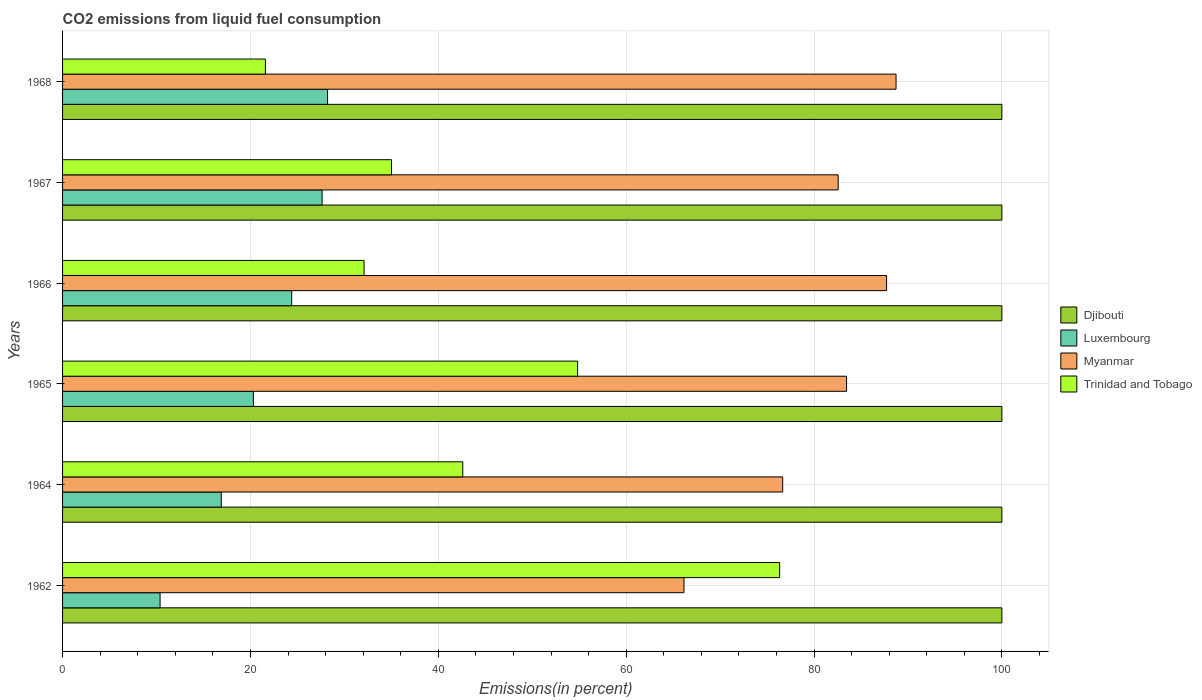How many groups of bars are there?
Your response must be concise. 6. Are the number of bars per tick equal to the number of legend labels?
Ensure brevity in your answer.  Yes. Are the number of bars on each tick of the Y-axis equal?
Your answer should be compact. Yes. What is the label of the 6th group of bars from the top?
Ensure brevity in your answer.  1962. What is the total CO2 emitted in Trinidad and Tobago in 1964?
Your response must be concise. 42.61. Across all years, what is the maximum total CO2 emitted in Trinidad and Tobago?
Offer a very short reply. 76.34. Across all years, what is the minimum total CO2 emitted in Djibouti?
Your answer should be compact. 100. In which year was the total CO2 emitted in Djibouti maximum?
Your answer should be very brief. 1962. In which year was the total CO2 emitted in Trinidad and Tobago minimum?
Give a very brief answer. 1968. What is the total total CO2 emitted in Trinidad and Tobago in the graph?
Keep it short and to the point. 262.5. What is the difference between the total CO2 emitted in Myanmar in 1967 and that in 1968?
Your answer should be very brief. -6.16. What is the difference between the total CO2 emitted in Luxembourg in 1966 and the total CO2 emitted in Myanmar in 1964?
Make the answer very short. -52.27. What is the average total CO2 emitted in Trinidad and Tobago per year?
Give a very brief answer. 43.75. In the year 1966, what is the difference between the total CO2 emitted in Trinidad and Tobago and total CO2 emitted in Luxembourg?
Keep it short and to the point. 7.71. In how many years, is the total CO2 emitted in Djibouti greater than 60 %?
Give a very brief answer. 6. What is the ratio of the total CO2 emitted in Luxembourg in 1965 to that in 1966?
Give a very brief answer. 0.83. Is the total CO2 emitted in Luxembourg in 1967 less than that in 1968?
Make the answer very short. Yes. What is the difference between the highest and the second highest total CO2 emitted in Trinidad and Tobago?
Provide a short and direct response. 21.51. What is the difference between the highest and the lowest total CO2 emitted in Trinidad and Tobago?
Make the answer very short. 54.75. Is the sum of the total CO2 emitted in Djibouti in 1966 and 1968 greater than the maximum total CO2 emitted in Myanmar across all years?
Offer a terse response. Yes. What does the 2nd bar from the top in 1966 represents?
Provide a short and direct response. Myanmar. What does the 1st bar from the bottom in 1966 represents?
Your answer should be compact. Djibouti. Is it the case that in every year, the sum of the total CO2 emitted in Djibouti and total CO2 emitted in Luxembourg is greater than the total CO2 emitted in Trinidad and Tobago?
Your answer should be very brief. Yes. Are all the bars in the graph horizontal?
Your response must be concise. Yes. How many years are there in the graph?
Offer a very short reply. 6. What is the difference between two consecutive major ticks on the X-axis?
Your answer should be compact. 20. Where does the legend appear in the graph?
Keep it short and to the point. Center right. How are the legend labels stacked?
Your answer should be very brief. Vertical. What is the title of the graph?
Offer a terse response. CO2 emissions from liquid fuel consumption. What is the label or title of the X-axis?
Your response must be concise. Emissions(in percent). What is the label or title of the Y-axis?
Keep it short and to the point. Years. What is the Emissions(in percent) in Djibouti in 1962?
Give a very brief answer. 100. What is the Emissions(in percent) of Luxembourg in 1962?
Your response must be concise. 10.38. What is the Emissions(in percent) in Myanmar in 1962?
Keep it short and to the point. 66.16. What is the Emissions(in percent) in Trinidad and Tobago in 1962?
Give a very brief answer. 76.34. What is the Emissions(in percent) of Luxembourg in 1964?
Your response must be concise. 16.9. What is the Emissions(in percent) of Myanmar in 1964?
Your response must be concise. 76.67. What is the Emissions(in percent) of Trinidad and Tobago in 1964?
Provide a succinct answer. 42.61. What is the Emissions(in percent) in Djibouti in 1965?
Your response must be concise. 100. What is the Emissions(in percent) in Luxembourg in 1965?
Make the answer very short. 20.31. What is the Emissions(in percent) of Myanmar in 1965?
Offer a very short reply. 83.47. What is the Emissions(in percent) of Trinidad and Tobago in 1965?
Your answer should be compact. 54.83. What is the Emissions(in percent) of Luxembourg in 1966?
Ensure brevity in your answer.  24.39. What is the Emissions(in percent) in Myanmar in 1966?
Provide a short and direct response. 87.73. What is the Emissions(in percent) in Trinidad and Tobago in 1966?
Make the answer very short. 32.1. What is the Emissions(in percent) in Luxembourg in 1967?
Provide a short and direct response. 27.63. What is the Emissions(in percent) of Myanmar in 1967?
Your answer should be very brief. 82.57. What is the Emissions(in percent) in Trinidad and Tobago in 1967?
Provide a short and direct response. 35.02. What is the Emissions(in percent) of Luxembourg in 1968?
Make the answer very short. 28.21. What is the Emissions(in percent) in Myanmar in 1968?
Your answer should be compact. 88.74. What is the Emissions(in percent) of Trinidad and Tobago in 1968?
Your answer should be compact. 21.6. Across all years, what is the maximum Emissions(in percent) in Djibouti?
Provide a short and direct response. 100. Across all years, what is the maximum Emissions(in percent) of Luxembourg?
Keep it short and to the point. 28.21. Across all years, what is the maximum Emissions(in percent) of Myanmar?
Provide a short and direct response. 88.74. Across all years, what is the maximum Emissions(in percent) in Trinidad and Tobago?
Keep it short and to the point. 76.34. Across all years, what is the minimum Emissions(in percent) of Djibouti?
Provide a succinct answer. 100. Across all years, what is the minimum Emissions(in percent) in Luxembourg?
Your response must be concise. 10.38. Across all years, what is the minimum Emissions(in percent) of Myanmar?
Your answer should be very brief. 66.16. Across all years, what is the minimum Emissions(in percent) of Trinidad and Tobago?
Make the answer very short. 21.6. What is the total Emissions(in percent) of Djibouti in the graph?
Your answer should be very brief. 600. What is the total Emissions(in percent) of Luxembourg in the graph?
Offer a very short reply. 127.82. What is the total Emissions(in percent) in Myanmar in the graph?
Your answer should be compact. 485.33. What is the total Emissions(in percent) of Trinidad and Tobago in the graph?
Keep it short and to the point. 262.5. What is the difference between the Emissions(in percent) in Luxembourg in 1962 and that in 1964?
Your answer should be compact. -6.51. What is the difference between the Emissions(in percent) in Myanmar in 1962 and that in 1964?
Provide a succinct answer. -10.51. What is the difference between the Emissions(in percent) of Trinidad and Tobago in 1962 and that in 1964?
Offer a terse response. 33.73. What is the difference between the Emissions(in percent) of Luxembourg in 1962 and that in 1965?
Your answer should be compact. -9.93. What is the difference between the Emissions(in percent) of Myanmar in 1962 and that in 1965?
Your response must be concise. -17.31. What is the difference between the Emissions(in percent) of Trinidad and Tobago in 1962 and that in 1965?
Provide a succinct answer. 21.51. What is the difference between the Emissions(in percent) in Djibouti in 1962 and that in 1966?
Your answer should be compact. 0. What is the difference between the Emissions(in percent) in Luxembourg in 1962 and that in 1966?
Provide a short and direct response. -14.01. What is the difference between the Emissions(in percent) in Myanmar in 1962 and that in 1966?
Offer a very short reply. -21.57. What is the difference between the Emissions(in percent) in Trinidad and Tobago in 1962 and that in 1966?
Your answer should be compact. 44.24. What is the difference between the Emissions(in percent) in Luxembourg in 1962 and that in 1967?
Provide a succinct answer. -17.25. What is the difference between the Emissions(in percent) of Myanmar in 1962 and that in 1967?
Give a very brief answer. -16.42. What is the difference between the Emissions(in percent) in Trinidad and Tobago in 1962 and that in 1967?
Give a very brief answer. 41.32. What is the difference between the Emissions(in percent) of Luxembourg in 1962 and that in 1968?
Give a very brief answer. -17.83. What is the difference between the Emissions(in percent) of Myanmar in 1962 and that in 1968?
Your answer should be very brief. -22.58. What is the difference between the Emissions(in percent) of Trinidad and Tobago in 1962 and that in 1968?
Your answer should be very brief. 54.75. What is the difference between the Emissions(in percent) in Djibouti in 1964 and that in 1965?
Provide a succinct answer. 0. What is the difference between the Emissions(in percent) in Luxembourg in 1964 and that in 1965?
Keep it short and to the point. -3.42. What is the difference between the Emissions(in percent) in Myanmar in 1964 and that in 1965?
Offer a very short reply. -6.8. What is the difference between the Emissions(in percent) in Trinidad and Tobago in 1964 and that in 1965?
Keep it short and to the point. -12.23. What is the difference between the Emissions(in percent) in Djibouti in 1964 and that in 1966?
Your response must be concise. 0. What is the difference between the Emissions(in percent) in Luxembourg in 1964 and that in 1966?
Provide a succinct answer. -7.5. What is the difference between the Emissions(in percent) of Myanmar in 1964 and that in 1966?
Your response must be concise. -11.06. What is the difference between the Emissions(in percent) of Trinidad and Tobago in 1964 and that in 1966?
Ensure brevity in your answer.  10.51. What is the difference between the Emissions(in percent) of Luxembourg in 1964 and that in 1967?
Make the answer very short. -10.74. What is the difference between the Emissions(in percent) in Myanmar in 1964 and that in 1967?
Your response must be concise. -5.91. What is the difference between the Emissions(in percent) in Trinidad and Tobago in 1964 and that in 1967?
Offer a very short reply. 7.59. What is the difference between the Emissions(in percent) of Luxembourg in 1964 and that in 1968?
Provide a short and direct response. -11.32. What is the difference between the Emissions(in percent) in Myanmar in 1964 and that in 1968?
Ensure brevity in your answer.  -12.07. What is the difference between the Emissions(in percent) of Trinidad and Tobago in 1964 and that in 1968?
Offer a terse response. 21.01. What is the difference between the Emissions(in percent) in Luxembourg in 1965 and that in 1966?
Make the answer very short. -4.08. What is the difference between the Emissions(in percent) in Myanmar in 1965 and that in 1966?
Offer a terse response. -4.26. What is the difference between the Emissions(in percent) in Trinidad and Tobago in 1965 and that in 1966?
Make the answer very short. 22.74. What is the difference between the Emissions(in percent) of Djibouti in 1965 and that in 1967?
Your answer should be compact. 0. What is the difference between the Emissions(in percent) in Luxembourg in 1965 and that in 1967?
Give a very brief answer. -7.32. What is the difference between the Emissions(in percent) of Myanmar in 1965 and that in 1967?
Provide a succinct answer. 0.89. What is the difference between the Emissions(in percent) in Trinidad and Tobago in 1965 and that in 1967?
Ensure brevity in your answer.  19.81. What is the difference between the Emissions(in percent) of Luxembourg in 1965 and that in 1968?
Offer a very short reply. -7.9. What is the difference between the Emissions(in percent) of Myanmar in 1965 and that in 1968?
Your response must be concise. -5.27. What is the difference between the Emissions(in percent) of Trinidad and Tobago in 1965 and that in 1968?
Offer a very short reply. 33.24. What is the difference between the Emissions(in percent) of Luxembourg in 1966 and that in 1967?
Keep it short and to the point. -3.24. What is the difference between the Emissions(in percent) of Myanmar in 1966 and that in 1967?
Make the answer very short. 5.16. What is the difference between the Emissions(in percent) of Trinidad and Tobago in 1966 and that in 1967?
Your response must be concise. -2.92. What is the difference between the Emissions(in percent) of Luxembourg in 1966 and that in 1968?
Keep it short and to the point. -3.82. What is the difference between the Emissions(in percent) of Myanmar in 1966 and that in 1968?
Keep it short and to the point. -1.01. What is the difference between the Emissions(in percent) of Trinidad and Tobago in 1966 and that in 1968?
Your response must be concise. 10.5. What is the difference between the Emissions(in percent) of Luxembourg in 1967 and that in 1968?
Offer a very short reply. -0.58. What is the difference between the Emissions(in percent) in Myanmar in 1967 and that in 1968?
Your answer should be compact. -6.16. What is the difference between the Emissions(in percent) in Trinidad and Tobago in 1967 and that in 1968?
Offer a very short reply. 13.42. What is the difference between the Emissions(in percent) of Djibouti in 1962 and the Emissions(in percent) of Luxembourg in 1964?
Your answer should be very brief. 83.1. What is the difference between the Emissions(in percent) of Djibouti in 1962 and the Emissions(in percent) of Myanmar in 1964?
Ensure brevity in your answer.  23.33. What is the difference between the Emissions(in percent) in Djibouti in 1962 and the Emissions(in percent) in Trinidad and Tobago in 1964?
Your response must be concise. 57.39. What is the difference between the Emissions(in percent) in Luxembourg in 1962 and the Emissions(in percent) in Myanmar in 1964?
Offer a very short reply. -66.29. What is the difference between the Emissions(in percent) in Luxembourg in 1962 and the Emissions(in percent) in Trinidad and Tobago in 1964?
Your response must be concise. -32.23. What is the difference between the Emissions(in percent) of Myanmar in 1962 and the Emissions(in percent) of Trinidad and Tobago in 1964?
Your response must be concise. 23.55. What is the difference between the Emissions(in percent) in Djibouti in 1962 and the Emissions(in percent) in Luxembourg in 1965?
Your answer should be very brief. 79.69. What is the difference between the Emissions(in percent) in Djibouti in 1962 and the Emissions(in percent) in Myanmar in 1965?
Make the answer very short. 16.53. What is the difference between the Emissions(in percent) of Djibouti in 1962 and the Emissions(in percent) of Trinidad and Tobago in 1965?
Keep it short and to the point. 45.17. What is the difference between the Emissions(in percent) of Luxembourg in 1962 and the Emissions(in percent) of Myanmar in 1965?
Offer a very short reply. -73.09. What is the difference between the Emissions(in percent) in Luxembourg in 1962 and the Emissions(in percent) in Trinidad and Tobago in 1965?
Offer a terse response. -44.45. What is the difference between the Emissions(in percent) in Myanmar in 1962 and the Emissions(in percent) in Trinidad and Tobago in 1965?
Your answer should be compact. 11.32. What is the difference between the Emissions(in percent) in Djibouti in 1962 and the Emissions(in percent) in Luxembourg in 1966?
Ensure brevity in your answer.  75.61. What is the difference between the Emissions(in percent) in Djibouti in 1962 and the Emissions(in percent) in Myanmar in 1966?
Provide a succinct answer. 12.27. What is the difference between the Emissions(in percent) of Djibouti in 1962 and the Emissions(in percent) of Trinidad and Tobago in 1966?
Make the answer very short. 67.9. What is the difference between the Emissions(in percent) in Luxembourg in 1962 and the Emissions(in percent) in Myanmar in 1966?
Your response must be concise. -77.35. What is the difference between the Emissions(in percent) of Luxembourg in 1962 and the Emissions(in percent) of Trinidad and Tobago in 1966?
Your answer should be very brief. -21.72. What is the difference between the Emissions(in percent) in Myanmar in 1962 and the Emissions(in percent) in Trinidad and Tobago in 1966?
Offer a terse response. 34.06. What is the difference between the Emissions(in percent) of Djibouti in 1962 and the Emissions(in percent) of Luxembourg in 1967?
Your answer should be compact. 72.37. What is the difference between the Emissions(in percent) in Djibouti in 1962 and the Emissions(in percent) in Myanmar in 1967?
Your response must be concise. 17.43. What is the difference between the Emissions(in percent) of Djibouti in 1962 and the Emissions(in percent) of Trinidad and Tobago in 1967?
Your answer should be compact. 64.98. What is the difference between the Emissions(in percent) in Luxembourg in 1962 and the Emissions(in percent) in Myanmar in 1967?
Your answer should be very brief. -72.19. What is the difference between the Emissions(in percent) in Luxembourg in 1962 and the Emissions(in percent) in Trinidad and Tobago in 1967?
Provide a short and direct response. -24.64. What is the difference between the Emissions(in percent) of Myanmar in 1962 and the Emissions(in percent) of Trinidad and Tobago in 1967?
Provide a short and direct response. 31.14. What is the difference between the Emissions(in percent) of Djibouti in 1962 and the Emissions(in percent) of Luxembourg in 1968?
Provide a succinct answer. 71.79. What is the difference between the Emissions(in percent) in Djibouti in 1962 and the Emissions(in percent) in Myanmar in 1968?
Make the answer very short. 11.26. What is the difference between the Emissions(in percent) in Djibouti in 1962 and the Emissions(in percent) in Trinidad and Tobago in 1968?
Offer a very short reply. 78.4. What is the difference between the Emissions(in percent) of Luxembourg in 1962 and the Emissions(in percent) of Myanmar in 1968?
Your answer should be very brief. -78.36. What is the difference between the Emissions(in percent) in Luxembourg in 1962 and the Emissions(in percent) in Trinidad and Tobago in 1968?
Offer a very short reply. -11.22. What is the difference between the Emissions(in percent) in Myanmar in 1962 and the Emissions(in percent) in Trinidad and Tobago in 1968?
Your answer should be compact. 44.56. What is the difference between the Emissions(in percent) in Djibouti in 1964 and the Emissions(in percent) in Luxembourg in 1965?
Make the answer very short. 79.69. What is the difference between the Emissions(in percent) in Djibouti in 1964 and the Emissions(in percent) in Myanmar in 1965?
Offer a very short reply. 16.53. What is the difference between the Emissions(in percent) of Djibouti in 1964 and the Emissions(in percent) of Trinidad and Tobago in 1965?
Offer a terse response. 45.17. What is the difference between the Emissions(in percent) of Luxembourg in 1964 and the Emissions(in percent) of Myanmar in 1965?
Your answer should be very brief. -66.57. What is the difference between the Emissions(in percent) in Luxembourg in 1964 and the Emissions(in percent) in Trinidad and Tobago in 1965?
Keep it short and to the point. -37.94. What is the difference between the Emissions(in percent) in Myanmar in 1964 and the Emissions(in percent) in Trinidad and Tobago in 1965?
Provide a short and direct response. 21.83. What is the difference between the Emissions(in percent) in Djibouti in 1964 and the Emissions(in percent) in Luxembourg in 1966?
Offer a terse response. 75.61. What is the difference between the Emissions(in percent) of Djibouti in 1964 and the Emissions(in percent) of Myanmar in 1966?
Give a very brief answer. 12.27. What is the difference between the Emissions(in percent) in Djibouti in 1964 and the Emissions(in percent) in Trinidad and Tobago in 1966?
Your answer should be compact. 67.9. What is the difference between the Emissions(in percent) of Luxembourg in 1964 and the Emissions(in percent) of Myanmar in 1966?
Provide a short and direct response. -70.83. What is the difference between the Emissions(in percent) in Luxembourg in 1964 and the Emissions(in percent) in Trinidad and Tobago in 1966?
Keep it short and to the point. -15.2. What is the difference between the Emissions(in percent) in Myanmar in 1964 and the Emissions(in percent) in Trinidad and Tobago in 1966?
Your answer should be very brief. 44.57. What is the difference between the Emissions(in percent) in Djibouti in 1964 and the Emissions(in percent) in Luxembourg in 1967?
Your response must be concise. 72.37. What is the difference between the Emissions(in percent) in Djibouti in 1964 and the Emissions(in percent) in Myanmar in 1967?
Give a very brief answer. 17.43. What is the difference between the Emissions(in percent) in Djibouti in 1964 and the Emissions(in percent) in Trinidad and Tobago in 1967?
Offer a very short reply. 64.98. What is the difference between the Emissions(in percent) of Luxembourg in 1964 and the Emissions(in percent) of Myanmar in 1967?
Provide a succinct answer. -65.68. What is the difference between the Emissions(in percent) in Luxembourg in 1964 and the Emissions(in percent) in Trinidad and Tobago in 1967?
Provide a succinct answer. -18.12. What is the difference between the Emissions(in percent) of Myanmar in 1964 and the Emissions(in percent) of Trinidad and Tobago in 1967?
Your answer should be compact. 41.65. What is the difference between the Emissions(in percent) of Djibouti in 1964 and the Emissions(in percent) of Luxembourg in 1968?
Provide a short and direct response. 71.79. What is the difference between the Emissions(in percent) in Djibouti in 1964 and the Emissions(in percent) in Myanmar in 1968?
Offer a terse response. 11.26. What is the difference between the Emissions(in percent) of Djibouti in 1964 and the Emissions(in percent) of Trinidad and Tobago in 1968?
Your answer should be very brief. 78.4. What is the difference between the Emissions(in percent) of Luxembourg in 1964 and the Emissions(in percent) of Myanmar in 1968?
Provide a succinct answer. -71.84. What is the difference between the Emissions(in percent) in Luxembourg in 1964 and the Emissions(in percent) in Trinidad and Tobago in 1968?
Provide a succinct answer. -4.7. What is the difference between the Emissions(in percent) in Myanmar in 1964 and the Emissions(in percent) in Trinidad and Tobago in 1968?
Provide a succinct answer. 55.07. What is the difference between the Emissions(in percent) of Djibouti in 1965 and the Emissions(in percent) of Luxembourg in 1966?
Keep it short and to the point. 75.61. What is the difference between the Emissions(in percent) of Djibouti in 1965 and the Emissions(in percent) of Myanmar in 1966?
Make the answer very short. 12.27. What is the difference between the Emissions(in percent) of Djibouti in 1965 and the Emissions(in percent) of Trinidad and Tobago in 1966?
Your answer should be compact. 67.9. What is the difference between the Emissions(in percent) of Luxembourg in 1965 and the Emissions(in percent) of Myanmar in 1966?
Your answer should be very brief. -67.42. What is the difference between the Emissions(in percent) in Luxembourg in 1965 and the Emissions(in percent) in Trinidad and Tobago in 1966?
Your response must be concise. -11.79. What is the difference between the Emissions(in percent) in Myanmar in 1965 and the Emissions(in percent) in Trinidad and Tobago in 1966?
Your response must be concise. 51.37. What is the difference between the Emissions(in percent) of Djibouti in 1965 and the Emissions(in percent) of Luxembourg in 1967?
Your response must be concise. 72.37. What is the difference between the Emissions(in percent) in Djibouti in 1965 and the Emissions(in percent) in Myanmar in 1967?
Your response must be concise. 17.43. What is the difference between the Emissions(in percent) of Djibouti in 1965 and the Emissions(in percent) of Trinidad and Tobago in 1967?
Your answer should be very brief. 64.98. What is the difference between the Emissions(in percent) of Luxembourg in 1965 and the Emissions(in percent) of Myanmar in 1967?
Offer a terse response. -62.26. What is the difference between the Emissions(in percent) of Luxembourg in 1965 and the Emissions(in percent) of Trinidad and Tobago in 1967?
Your answer should be very brief. -14.71. What is the difference between the Emissions(in percent) in Myanmar in 1965 and the Emissions(in percent) in Trinidad and Tobago in 1967?
Offer a terse response. 48.45. What is the difference between the Emissions(in percent) in Djibouti in 1965 and the Emissions(in percent) in Luxembourg in 1968?
Offer a very short reply. 71.79. What is the difference between the Emissions(in percent) of Djibouti in 1965 and the Emissions(in percent) of Myanmar in 1968?
Ensure brevity in your answer.  11.26. What is the difference between the Emissions(in percent) of Djibouti in 1965 and the Emissions(in percent) of Trinidad and Tobago in 1968?
Make the answer very short. 78.4. What is the difference between the Emissions(in percent) of Luxembourg in 1965 and the Emissions(in percent) of Myanmar in 1968?
Your answer should be very brief. -68.42. What is the difference between the Emissions(in percent) of Luxembourg in 1965 and the Emissions(in percent) of Trinidad and Tobago in 1968?
Provide a succinct answer. -1.28. What is the difference between the Emissions(in percent) in Myanmar in 1965 and the Emissions(in percent) in Trinidad and Tobago in 1968?
Offer a terse response. 61.87. What is the difference between the Emissions(in percent) of Djibouti in 1966 and the Emissions(in percent) of Luxembourg in 1967?
Give a very brief answer. 72.37. What is the difference between the Emissions(in percent) of Djibouti in 1966 and the Emissions(in percent) of Myanmar in 1967?
Offer a very short reply. 17.43. What is the difference between the Emissions(in percent) of Djibouti in 1966 and the Emissions(in percent) of Trinidad and Tobago in 1967?
Your answer should be very brief. 64.98. What is the difference between the Emissions(in percent) of Luxembourg in 1966 and the Emissions(in percent) of Myanmar in 1967?
Ensure brevity in your answer.  -58.18. What is the difference between the Emissions(in percent) of Luxembourg in 1966 and the Emissions(in percent) of Trinidad and Tobago in 1967?
Ensure brevity in your answer.  -10.63. What is the difference between the Emissions(in percent) of Myanmar in 1966 and the Emissions(in percent) of Trinidad and Tobago in 1967?
Ensure brevity in your answer.  52.71. What is the difference between the Emissions(in percent) in Djibouti in 1966 and the Emissions(in percent) in Luxembourg in 1968?
Ensure brevity in your answer.  71.79. What is the difference between the Emissions(in percent) in Djibouti in 1966 and the Emissions(in percent) in Myanmar in 1968?
Provide a short and direct response. 11.26. What is the difference between the Emissions(in percent) of Djibouti in 1966 and the Emissions(in percent) of Trinidad and Tobago in 1968?
Keep it short and to the point. 78.4. What is the difference between the Emissions(in percent) of Luxembourg in 1966 and the Emissions(in percent) of Myanmar in 1968?
Keep it short and to the point. -64.34. What is the difference between the Emissions(in percent) in Luxembourg in 1966 and the Emissions(in percent) in Trinidad and Tobago in 1968?
Offer a terse response. 2.8. What is the difference between the Emissions(in percent) of Myanmar in 1966 and the Emissions(in percent) of Trinidad and Tobago in 1968?
Provide a short and direct response. 66.13. What is the difference between the Emissions(in percent) in Djibouti in 1967 and the Emissions(in percent) in Luxembourg in 1968?
Ensure brevity in your answer.  71.79. What is the difference between the Emissions(in percent) in Djibouti in 1967 and the Emissions(in percent) in Myanmar in 1968?
Offer a terse response. 11.26. What is the difference between the Emissions(in percent) in Djibouti in 1967 and the Emissions(in percent) in Trinidad and Tobago in 1968?
Keep it short and to the point. 78.4. What is the difference between the Emissions(in percent) in Luxembourg in 1967 and the Emissions(in percent) in Myanmar in 1968?
Offer a terse response. -61.11. What is the difference between the Emissions(in percent) in Luxembourg in 1967 and the Emissions(in percent) in Trinidad and Tobago in 1968?
Make the answer very short. 6.03. What is the difference between the Emissions(in percent) in Myanmar in 1967 and the Emissions(in percent) in Trinidad and Tobago in 1968?
Your answer should be compact. 60.98. What is the average Emissions(in percent) in Djibouti per year?
Ensure brevity in your answer.  100. What is the average Emissions(in percent) of Luxembourg per year?
Provide a short and direct response. 21.3. What is the average Emissions(in percent) of Myanmar per year?
Your answer should be compact. 80.89. What is the average Emissions(in percent) of Trinidad and Tobago per year?
Your response must be concise. 43.75. In the year 1962, what is the difference between the Emissions(in percent) in Djibouti and Emissions(in percent) in Luxembourg?
Your answer should be compact. 89.62. In the year 1962, what is the difference between the Emissions(in percent) of Djibouti and Emissions(in percent) of Myanmar?
Your response must be concise. 33.84. In the year 1962, what is the difference between the Emissions(in percent) of Djibouti and Emissions(in percent) of Trinidad and Tobago?
Keep it short and to the point. 23.66. In the year 1962, what is the difference between the Emissions(in percent) of Luxembourg and Emissions(in percent) of Myanmar?
Your answer should be compact. -55.78. In the year 1962, what is the difference between the Emissions(in percent) in Luxembourg and Emissions(in percent) in Trinidad and Tobago?
Your answer should be very brief. -65.96. In the year 1962, what is the difference between the Emissions(in percent) in Myanmar and Emissions(in percent) in Trinidad and Tobago?
Your response must be concise. -10.18. In the year 1964, what is the difference between the Emissions(in percent) in Djibouti and Emissions(in percent) in Luxembourg?
Provide a succinct answer. 83.1. In the year 1964, what is the difference between the Emissions(in percent) of Djibouti and Emissions(in percent) of Myanmar?
Your answer should be compact. 23.33. In the year 1964, what is the difference between the Emissions(in percent) in Djibouti and Emissions(in percent) in Trinidad and Tobago?
Ensure brevity in your answer.  57.39. In the year 1964, what is the difference between the Emissions(in percent) in Luxembourg and Emissions(in percent) in Myanmar?
Your response must be concise. -59.77. In the year 1964, what is the difference between the Emissions(in percent) in Luxembourg and Emissions(in percent) in Trinidad and Tobago?
Offer a terse response. -25.71. In the year 1964, what is the difference between the Emissions(in percent) in Myanmar and Emissions(in percent) in Trinidad and Tobago?
Offer a very short reply. 34.06. In the year 1965, what is the difference between the Emissions(in percent) of Djibouti and Emissions(in percent) of Luxembourg?
Offer a terse response. 79.69. In the year 1965, what is the difference between the Emissions(in percent) of Djibouti and Emissions(in percent) of Myanmar?
Keep it short and to the point. 16.53. In the year 1965, what is the difference between the Emissions(in percent) of Djibouti and Emissions(in percent) of Trinidad and Tobago?
Your answer should be compact. 45.17. In the year 1965, what is the difference between the Emissions(in percent) of Luxembourg and Emissions(in percent) of Myanmar?
Your answer should be compact. -63.16. In the year 1965, what is the difference between the Emissions(in percent) in Luxembourg and Emissions(in percent) in Trinidad and Tobago?
Provide a succinct answer. -34.52. In the year 1965, what is the difference between the Emissions(in percent) of Myanmar and Emissions(in percent) of Trinidad and Tobago?
Ensure brevity in your answer.  28.63. In the year 1966, what is the difference between the Emissions(in percent) of Djibouti and Emissions(in percent) of Luxembourg?
Offer a terse response. 75.61. In the year 1966, what is the difference between the Emissions(in percent) of Djibouti and Emissions(in percent) of Myanmar?
Make the answer very short. 12.27. In the year 1966, what is the difference between the Emissions(in percent) in Djibouti and Emissions(in percent) in Trinidad and Tobago?
Offer a terse response. 67.9. In the year 1966, what is the difference between the Emissions(in percent) in Luxembourg and Emissions(in percent) in Myanmar?
Give a very brief answer. -63.34. In the year 1966, what is the difference between the Emissions(in percent) in Luxembourg and Emissions(in percent) in Trinidad and Tobago?
Keep it short and to the point. -7.71. In the year 1966, what is the difference between the Emissions(in percent) in Myanmar and Emissions(in percent) in Trinidad and Tobago?
Give a very brief answer. 55.63. In the year 1967, what is the difference between the Emissions(in percent) of Djibouti and Emissions(in percent) of Luxembourg?
Provide a succinct answer. 72.37. In the year 1967, what is the difference between the Emissions(in percent) of Djibouti and Emissions(in percent) of Myanmar?
Keep it short and to the point. 17.43. In the year 1967, what is the difference between the Emissions(in percent) in Djibouti and Emissions(in percent) in Trinidad and Tobago?
Give a very brief answer. 64.98. In the year 1967, what is the difference between the Emissions(in percent) in Luxembourg and Emissions(in percent) in Myanmar?
Give a very brief answer. -54.94. In the year 1967, what is the difference between the Emissions(in percent) in Luxembourg and Emissions(in percent) in Trinidad and Tobago?
Offer a very short reply. -7.39. In the year 1967, what is the difference between the Emissions(in percent) of Myanmar and Emissions(in percent) of Trinidad and Tobago?
Provide a succinct answer. 47.55. In the year 1968, what is the difference between the Emissions(in percent) in Djibouti and Emissions(in percent) in Luxembourg?
Provide a short and direct response. 71.79. In the year 1968, what is the difference between the Emissions(in percent) in Djibouti and Emissions(in percent) in Myanmar?
Your answer should be very brief. 11.26. In the year 1968, what is the difference between the Emissions(in percent) in Djibouti and Emissions(in percent) in Trinidad and Tobago?
Your answer should be compact. 78.4. In the year 1968, what is the difference between the Emissions(in percent) of Luxembourg and Emissions(in percent) of Myanmar?
Your answer should be compact. -60.52. In the year 1968, what is the difference between the Emissions(in percent) of Luxembourg and Emissions(in percent) of Trinidad and Tobago?
Your response must be concise. 6.62. In the year 1968, what is the difference between the Emissions(in percent) of Myanmar and Emissions(in percent) of Trinidad and Tobago?
Your response must be concise. 67.14. What is the ratio of the Emissions(in percent) of Luxembourg in 1962 to that in 1964?
Offer a terse response. 0.61. What is the ratio of the Emissions(in percent) of Myanmar in 1962 to that in 1964?
Your answer should be compact. 0.86. What is the ratio of the Emissions(in percent) in Trinidad and Tobago in 1962 to that in 1964?
Offer a very short reply. 1.79. What is the ratio of the Emissions(in percent) of Luxembourg in 1962 to that in 1965?
Provide a succinct answer. 0.51. What is the ratio of the Emissions(in percent) of Myanmar in 1962 to that in 1965?
Give a very brief answer. 0.79. What is the ratio of the Emissions(in percent) of Trinidad and Tobago in 1962 to that in 1965?
Ensure brevity in your answer.  1.39. What is the ratio of the Emissions(in percent) of Luxembourg in 1962 to that in 1966?
Give a very brief answer. 0.43. What is the ratio of the Emissions(in percent) of Myanmar in 1962 to that in 1966?
Your response must be concise. 0.75. What is the ratio of the Emissions(in percent) of Trinidad and Tobago in 1962 to that in 1966?
Your answer should be very brief. 2.38. What is the ratio of the Emissions(in percent) of Djibouti in 1962 to that in 1967?
Provide a short and direct response. 1. What is the ratio of the Emissions(in percent) in Luxembourg in 1962 to that in 1967?
Ensure brevity in your answer.  0.38. What is the ratio of the Emissions(in percent) of Myanmar in 1962 to that in 1967?
Your answer should be very brief. 0.8. What is the ratio of the Emissions(in percent) of Trinidad and Tobago in 1962 to that in 1967?
Provide a succinct answer. 2.18. What is the ratio of the Emissions(in percent) of Djibouti in 1962 to that in 1968?
Ensure brevity in your answer.  1. What is the ratio of the Emissions(in percent) of Luxembourg in 1962 to that in 1968?
Ensure brevity in your answer.  0.37. What is the ratio of the Emissions(in percent) in Myanmar in 1962 to that in 1968?
Provide a short and direct response. 0.75. What is the ratio of the Emissions(in percent) in Trinidad and Tobago in 1962 to that in 1968?
Your answer should be compact. 3.53. What is the ratio of the Emissions(in percent) in Djibouti in 1964 to that in 1965?
Give a very brief answer. 1. What is the ratio of the Emissions(in percent) of Luxembourg in 1964 to that in 1965?
Keep it short and to the point. 0.83. What is the ratio of the Emissions(in percent) in Myanmar in 1964 to that in 1965?
Provide a succinct answer. 0.92. What is the ratio of the Emissions(in percent) of Trinidad and Tobago in 1964 to that in 1965?
Give a very brief answer. 0.78. What is the ratio of the Emissions(in percent) of Djibouti in 1964 to that in 1966?
Provide a succinct answer. 1. What is the ratio of the Emissions(in percent) of Luxembourg in 1964 to that in 1966?
Provide a succinct answer. 0.69. What is the ratio of the Emissions(in percent) of Myanmar in 1964 to that in 1966?
Ensure brevity in your answer.  0.87. What is the ratio of the Emissions(in percent) in Trinidad and Tobago in 1964 to that in 1966?
Ensure brevity in your answer.  1.33. What is the ratio of the Emissions(in percent) of Luxembourg in 1964 to that in 1967?
Provide a succinct answer. 0.61. What is the ratio of the Emissions(in percent) in Myanmar in 1964 to that in 1967?
Give a very brief answer. 0.93. What is the ratio of the Emissions(in percent) in Trinidad and Tobago in 1964 to that in 1967?
Provide a short and direct response. 1.22. What is the ratio of the Emissions(in percent) of Djibouti in 1964 to that in 1968?
Give a very brief answer. 1. What is the ratio of the Emissions(in percent) of Luxembourg in 1964 to that in 1968?
Provide a succinct answer. 0.6. What is the ratio of the Emissions(in percent) of Myanmar in 1964 to that in 1968?
Offer a very short reply. 0.86. What is the ratio of the Emissions(in percent) of Trinidad and Tobago in 1964 to that in 1968?
Give a very brief answer. 1.97. What is the ratio of the Emissions(in percent) of Djibouti in 1965 to that in 1966?
Give a very brief answer. 1. What is the ratio of the Emissions(in percent) of Luxembourg in 1965 to that in 1966?
Your answer should be compact. 0.83. What is the ratio of the Emissions(in percent) of Myanmar in 1965 to that in 1966?
Ensure brevity in your answer.  0.95. What is the ratio of the Emissions(in percent) of Trinidad and Tobago in 1965 to that in 1966?
Your answer should be very brief. 1.71. What is the ratio of the Emissions(in percent) of Djibouti in 1965 to that in 1967?
Offer a terse response. 1. What is the ratio of the Emissions(in percent) of Luxembourg in 1965 to that in 1967?
Provide a succinct answer. 0.74. What is the ratio of the Emissions(in percent) of Myanmar in 1965 to that in 1967?
Your response must be concise. 1.01. What is the ratio of the Emissions(in percent) of Trinidad and Tobago in 1965 to that in 1967?
Keep it short and to the point. 1.57. What is the ratio of the Emissions(in percent) of Luxembourg in 1965 to that in 1968?
Make the answer very short. 0.72. What is the ratio of the Emissions(in percent) in Myanmar in 1965 to that in 1968?
Offer a very short reply. 0.94. What is the ratio of the Emissions(in percent) of Trinidad and Tobago in 1965 to that in 1968?
Offer a very short reply. 2.54. What is the ratio of the Emissions(in percent) of Luxembourg in 1966 to that in 1967?
Offer a terse response. 0.88. What is the ratio of the Emissions(in percent) of Myanmar in 1966 to that in 1967?
Your answer should be very brief. 1.06. What is the ratio of the Emissions(in percent) of Trinidad and Tobago in 1966 to that in 1967?
Provide a short and direct response. 0.92. What is the ratio of the Emissions(in percent) in Djibouti in 1966 to that in 1968?
Your response must be concise. 1. What is the ratio of the Emissions(in percent) of Luxembourg in 1966 to that in 1968?
Provide a succinct answer. 0.86. What is the ratio of the Emissions(in percent) in Trinidad and Tobago in 1966 to that in 1968?
Your answer should be very brief. 1.49. What is the ratio of the Emissions(in percent) of Luxembourg in 1967 to that in 1968?
Ensure brevity in your answer.  0.98. What is the ratio of the Emissions(in percent) in Myanmar in 1967 to that in 1968?
Give a very brief answer. 0.93. What is the ratio of the Emissions(in percent) in Trinidad and Tobago in 1967 to that in 1968?
Your answer should be very brief. 1.62. What is the difference between the highest and the second highest Emissions(in percent) in Luxembourg?
Provide a succinct answer. 0.58. What is the difference between the highest and the second highest Emissions(in percent) of Myanmar?
Give a very brief answer. 1.01. What is the difference between the highest and the second highest Emissions(in percent) of Trinidad and Tobago?
Offer a very short reply. 21.51. What is the difference between the highest and the lowest Emissions(in percent) of Djibouti?
Your response must be concise. 0. What is the difference between the highest and the lowest Emissions(in percent) in Luxembourg?
Give a very brief answer. 17.83. What is the difference between the highest and the lowest Emissions(in percent) of Myanmar?
Ensure brevity in your answer.  22.58. What is the difference between the highest and the lowest Emissions(in percent) of Trinidad and Tobago?
Your answer should be compact. 54.75. 